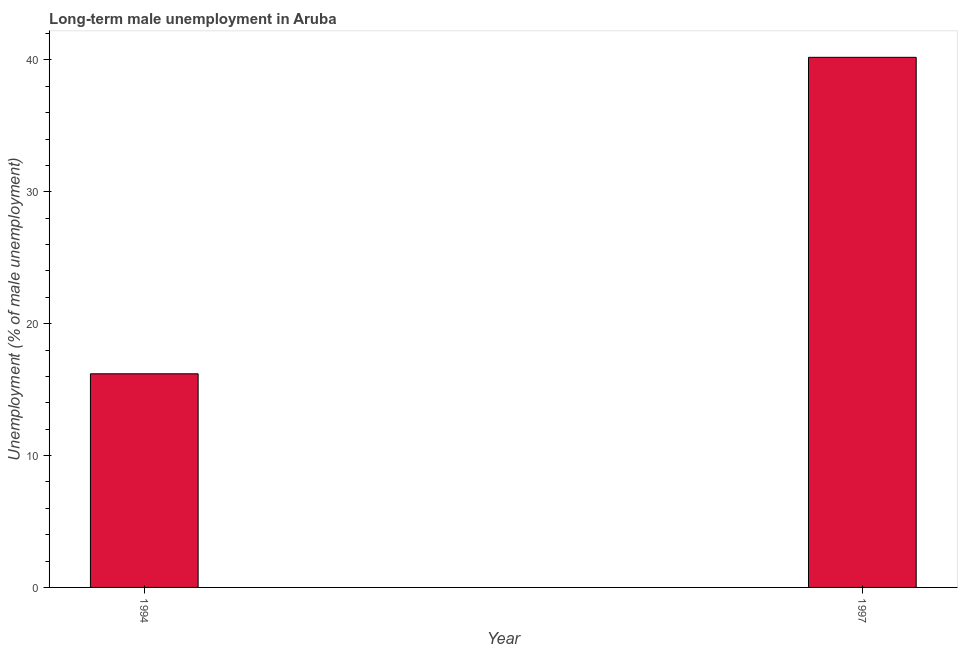What is the title of the graph?
Provide a succinct answer. Long-term male unemployment in Aruba. What is the label or title of the Y-axis?
Your answer should be compact. Unemployment (% of male unemployment). What is the long-term male unemployment in 1997?
Ensure brevity in your answer.  40.2. Across all years, what is the maximum long-term male unemployment?
Your answer should be very brief. 40.2. Across all years, what is the minimum long-term male unemployment?
Ensure brevity in your answer.  16.2. In which year was the long-term male unemployment maximum?
Keep it short and to the point. 1997. In which year was the long-term male unemployment minimum?
Provide a short and direct response. 1994. What is the sum of the long-term male unemployment?
Keep it short and to the point. 56.4. What is the average long-term male unemployment per year?
Provide a short and direct response. 28.2. What is the median long-term male unemployment?
Your response must be concise. 28.2. What is the ratio of the long-term male unemployment in 1994 to that in 1997?
Your answer should be very brief. 0.4. Is the long-term male unemployment in 1994 less than that in 1997?
Give a very brief answer. Yes. In how many years, is the long-term male unemployment greater than the average long-term male unemployment taken over all years?
Offer a very short reply. 1. Are all the bars in the graph horizontal?
Give a very brief answer. No. What is the Unemployment (% of male unemployment) in 1994?
Keep it short and to the point. 16.2. What is the Unemployment (% of male unemployment) in 1997?
Your answer should be compact. 40.2. What is the ratio of the Unemployment (% of male unemployment) in 1994 to that in 1997?
Offer a terse response. 0.4. 